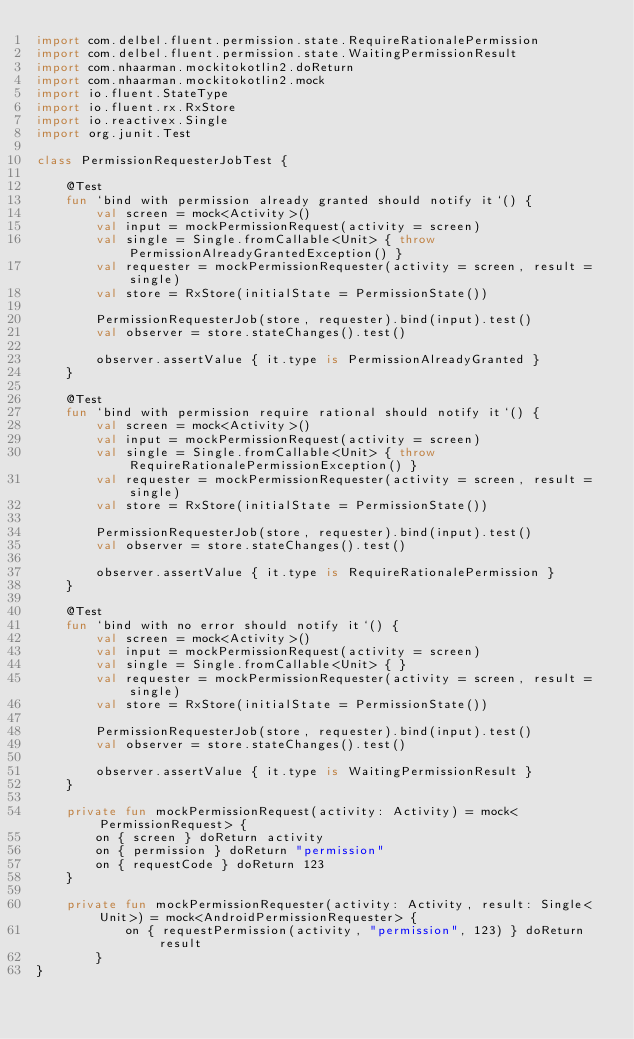Convert code to text. <code><loc_0><loc_0><loc_500><loc_500><_Kotlin_>import com.delbel.fluent.permission.state.RequireRationalePermission
import com.delbel.fluent.permission.state.WaitingPermissionResult
import com.nhaarman.mockitokotlin2.doReturn
import com.nhaarman.mockitokotlin2.mock
import io.fluent.StateType
import io.fluent.rx.RxStore
import io.reactivex.Single
import org.junit.Test

class PermissionRequesterJobTest {

    @Test
    fun `bind with permission already granted should notify it`() {
        val screen = mock<Activity>()
        val input = mockPermissionRequest(activity = screen)
        val single = Single.fromCallable<Unit> { throw PermissionAlreadyGrantedException() }
        val requester = mockPermissionRequester(activity = screen, result = single)
        val store = RxStore(initialState = PermissionState())

        PermissionRequesterJob(store, requester).bind(input).test()
        val observer = store.stateChanges().test()

        observer.assertValue { it.type is PermissionAlreadyGranted }
    }

    @Test
    fun `bind with permission require rational should notify it`() {
        val screen = mock<Activity>()
        val input = mockPermissionRequest(activity = screen)
        val single = Single.fromCallable<Unit> { throw RequireRationalePermissionException() }
        val requester = mockPermissionRequester(activity = screen, result = single)
        val store = RxStore(initialState = PermissionState())

        PermissionRequesterJob(store, requester).bind(input).test()
        val observer = store.stateChanges().test()

        observer.assertValue { it.type is RequireRationalePermission }
    }

    @Test
    fun `bind with no error should notify it`() {
        val screen = mock<Activity>()
        val input = mockPermissionRequest(activity = screen)
        val single = Single.fromCallable<Unit> { }
        val requester = mockPermissionRequester(activity = screen, result = single)
        val store = RxStore(initialState = PermissionState())

        PermissionRequesterJob(store, requester).bind(input).test()
        val observer = store.stateChanges().test()

        observer.assertValue { it.type is WaitingPermissionResult }
    }

    private fun mockPermissionRequest(activity: Activity) = mock<PermissionRequest> {
        on { screen } doReturn activity
        on { permission } doReturn "permission"
        on { requestCode } doReturn 123
    }

    private fun mockPermissionRequester(activity: Activity, result: Single<Unit>) = mock<AndroidPermissionRequester> {
            on { requestPermission(activity, "permission", 123) } doReturn result
        }
}</code> 